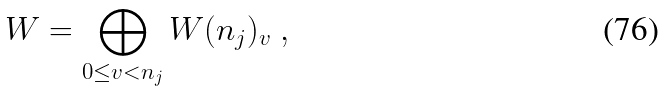<formula> <loc_0><loc_0><loc_500><loc_500>W = \bigoplus _ { 0 \leq v < n _ { j } } W ( n _ { j } ) _ { v } \ ,</formula> 